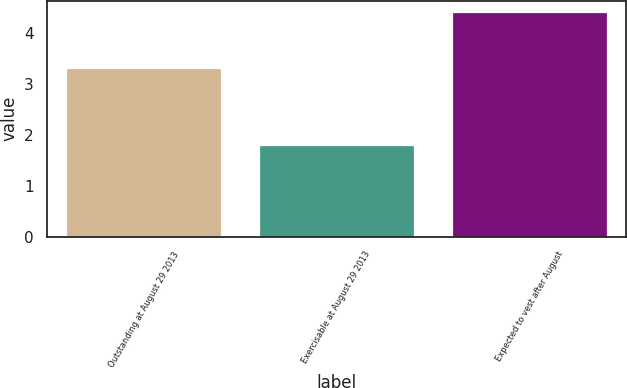Convert chart. <chart><loc_0><loc_0><loc_500><loc_500><bar_chart><fcel>Outstanding at August 29 2013<fcel>Exercisable at August 29 2013<fcel>Expected to vest after August<nl><fcel>3.3<fcel>1.8<fcel>4.4<nl></chart> 